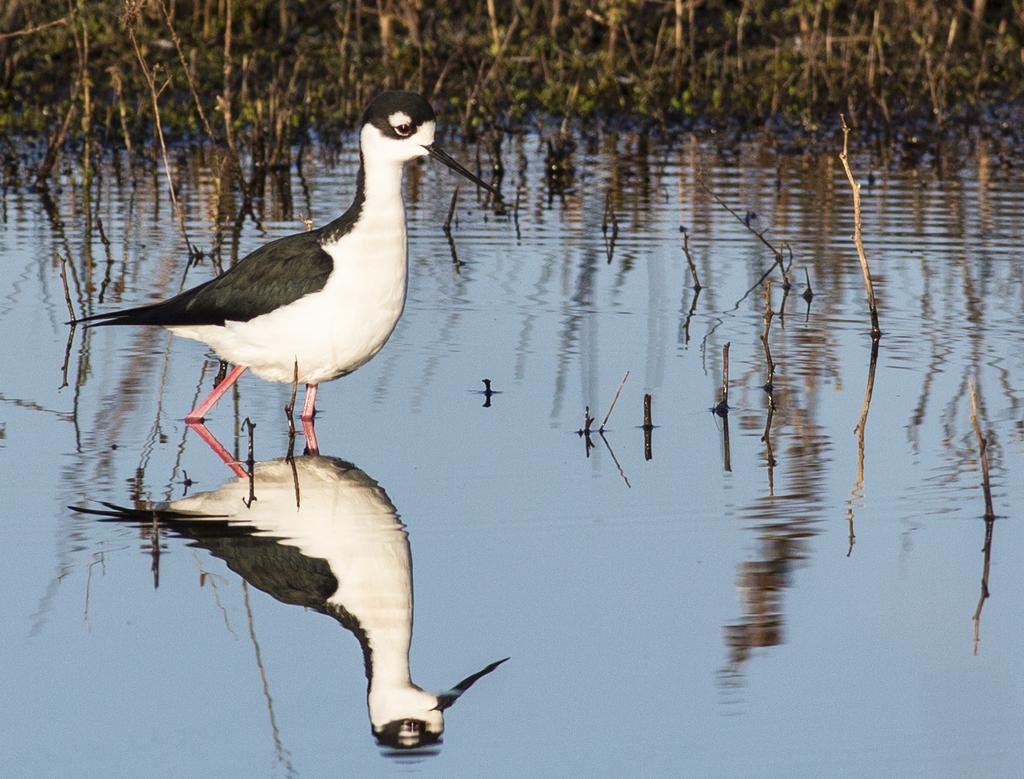What is the bird doing in the image? The bird is standing in the water. What can be seen in the background of the image? There are plants in the background of the image. What is a notable feature of the bird in the image? The bird's reflection is visible in the water. What type of treatment is the bird receiving for its injured wing in the image? There is no indication in the image that the bird has an injured wing or is receiving any treatment. 